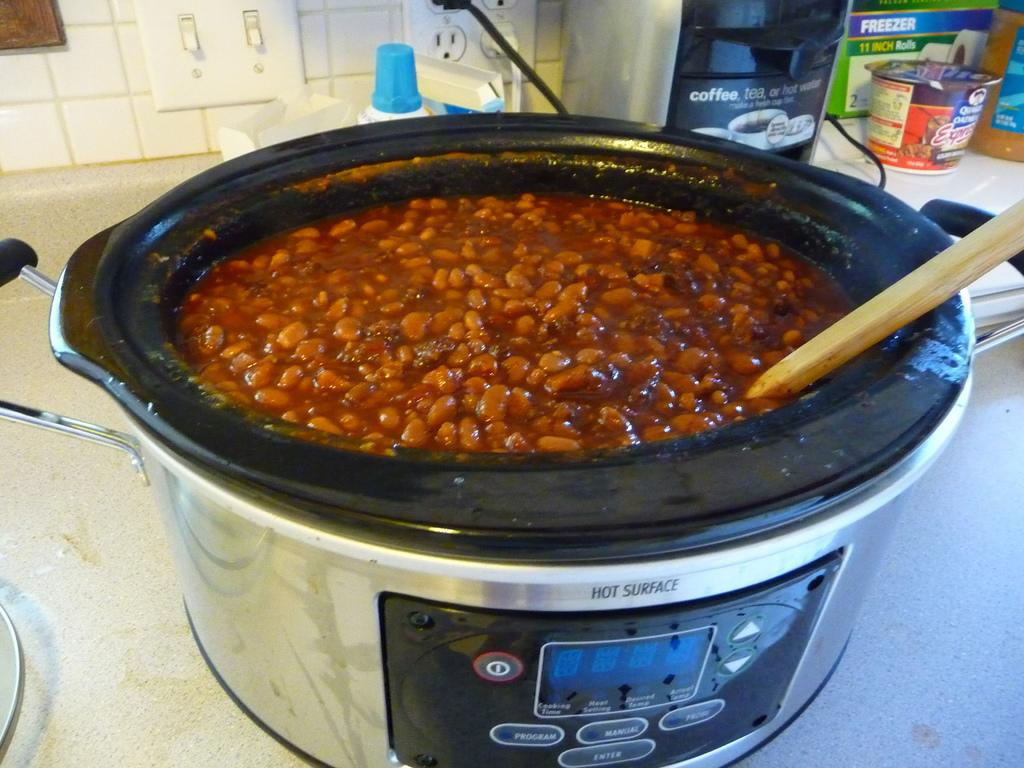<image>
Provide a brief description of the given image. Inside a slow cooker with a hot surface warning on the front, has a full batch of baked beans inside it. 